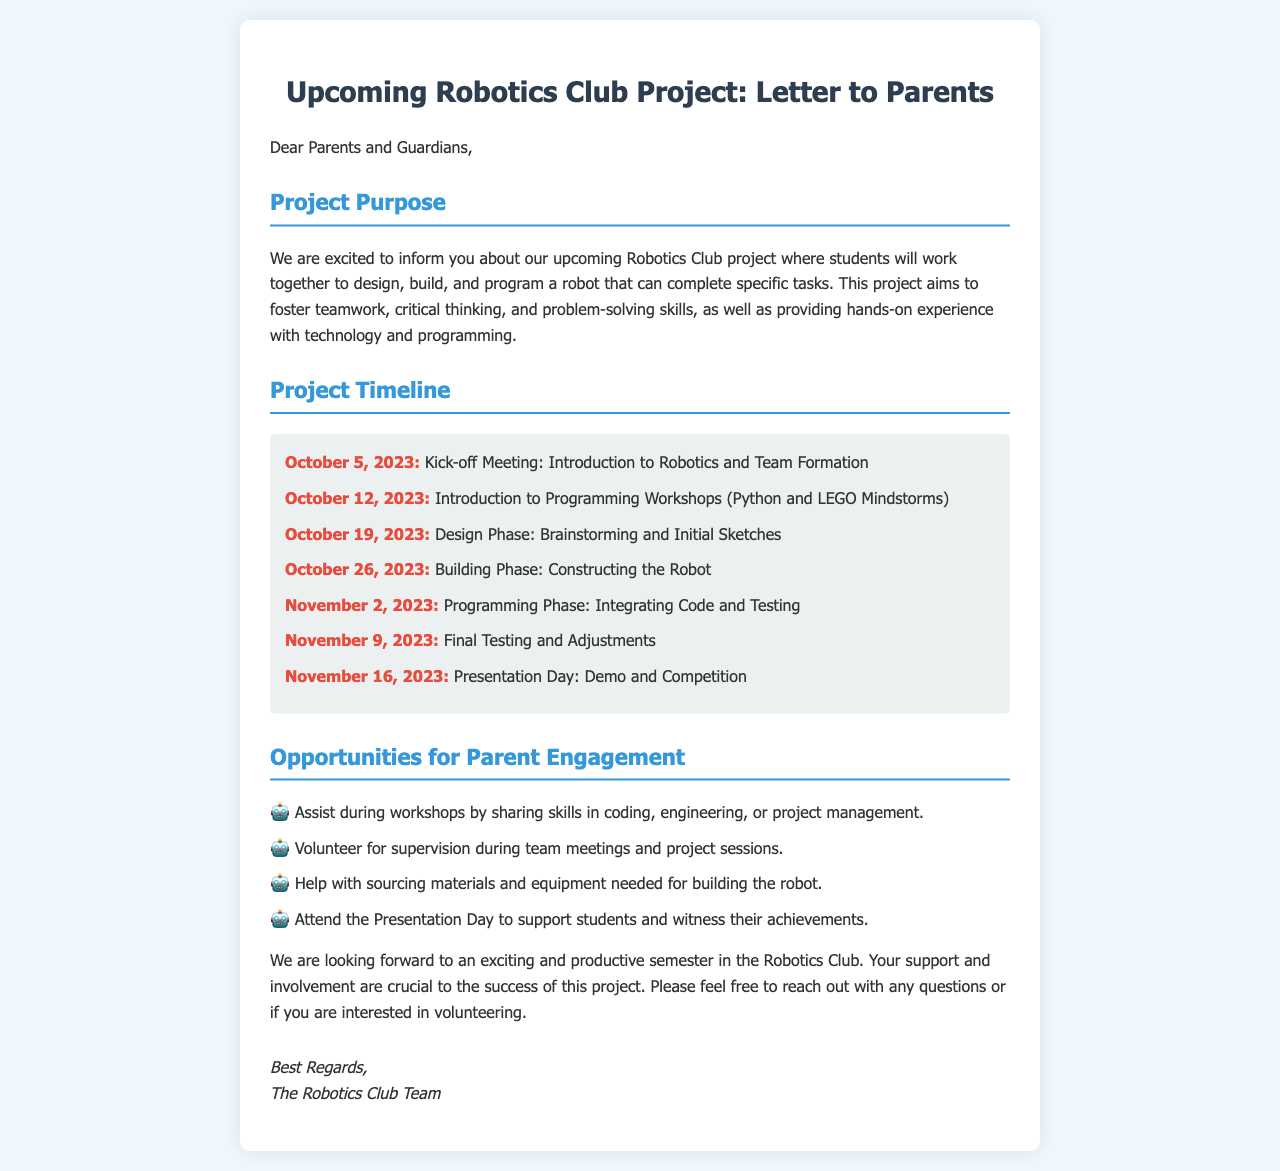What is the purpose of the Robotics Club project? The purpose is to foster teamwork, critical thinking, and problem-solving skills, as well as providing hands-on experience with technology and programming.
Answer: Foster teamwork When is the Presentation Day? The Presentation Day is when the students will demo their projects and compete, which is on November 16, 2023.
Answer: November 16, 2023 What will happen on October 19, 2023? On this date, students will enter the Design Phase where they will brainstorm and create initial sketches for the robot.
Answer: Design Phase How many opportunities for parental engagement are listed? There are four listed opportunities for parents to get involved in the project.
Answer: Four What programming language will be introduced during the workshops? The letter specifies that Python will be one of the programming languages introduced.
Answer: Python What is one example of how parents can assist during the project? Parents can assist by sharing skills in coding, engineering, or project management during the workshops.
Answer: Share skills What is the kick-off meeting date? The kick-off meeting will take place on October 5, 2023.
Answer: October 5, 2023 Who is signing off the letter? The letter is signed off by The Robotics Club Team.
Answer: The Robotics Club Team What phase follows the Building Phase? The phase that follows the Building Phase is the Programming Phase.
Answer: Programming Phase 